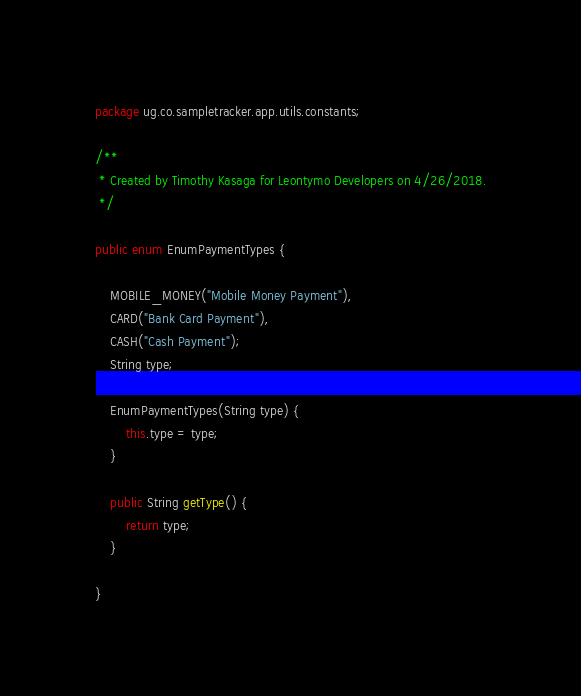<code> <loc_0><loc_0><loc_500><loc_500><_Java_>package ug.co.sampletracker.app.utils.constants;

/**
 * Created by Timothy Kasaga for Leontymo Developers on 4/26/2018.
 */

public enum EnumPaymentTypes {

    MOBILE_MONEY("Mobile Money Payment"),
    CARD("Bank Card Payment"),
    CASH("Cash Payment");
    String type;

    EnumPaymentTypes(String type) {
        this.type = type;
    }

    public String getType() {
        return type;
    }

}
</code> 